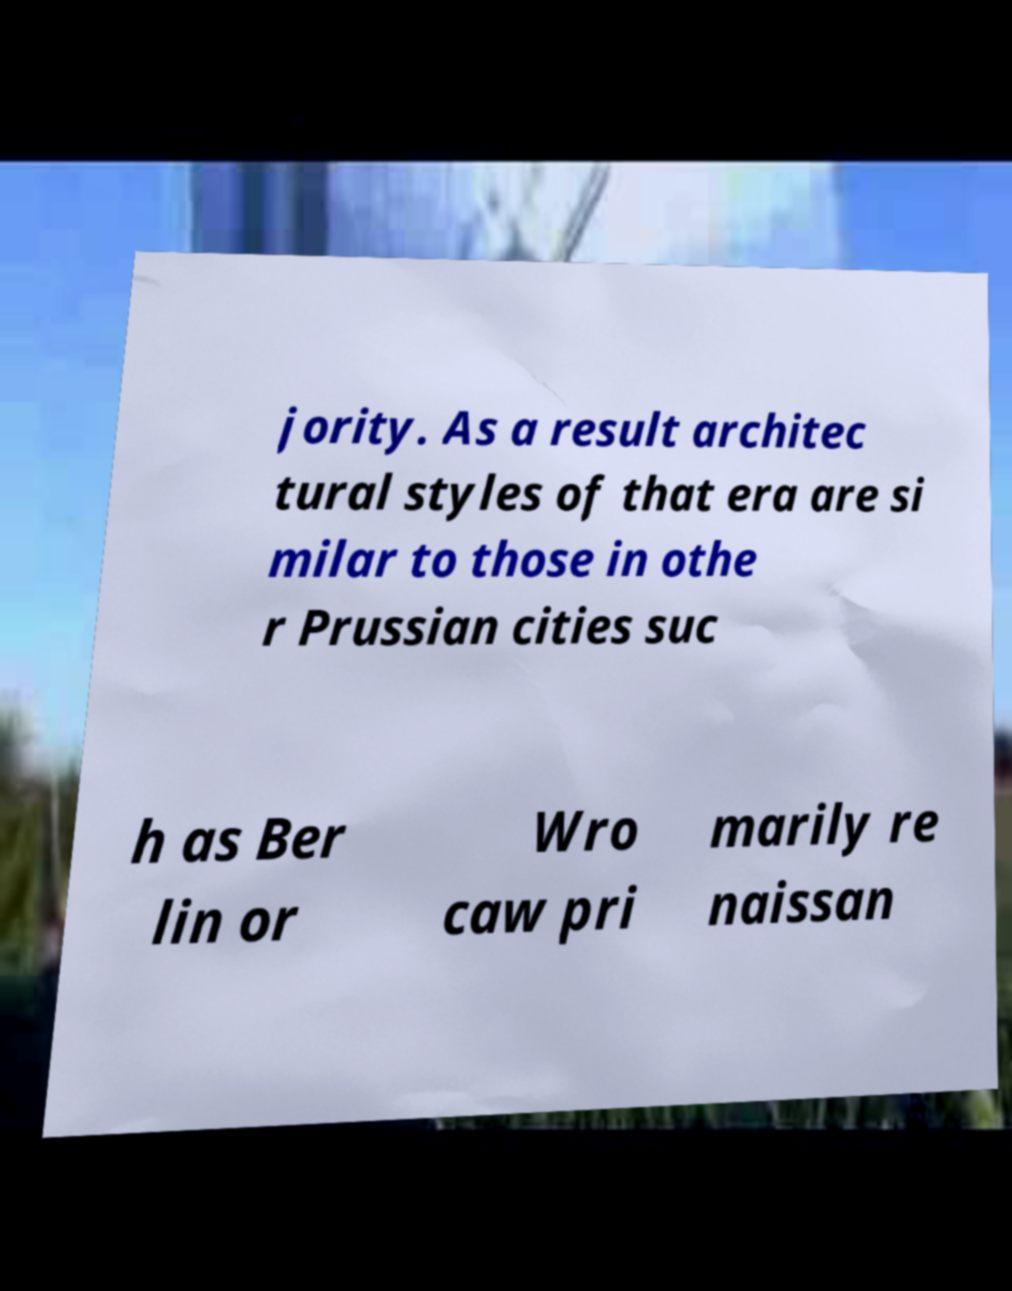There's text embedded in this image that I need extracted. Can you transcribe it verbatim? jority. As a result architec tural styles of that era are si milar to those in othe r Prussian cities suc h as Ber lin or Wro caw pri marily re naissan 